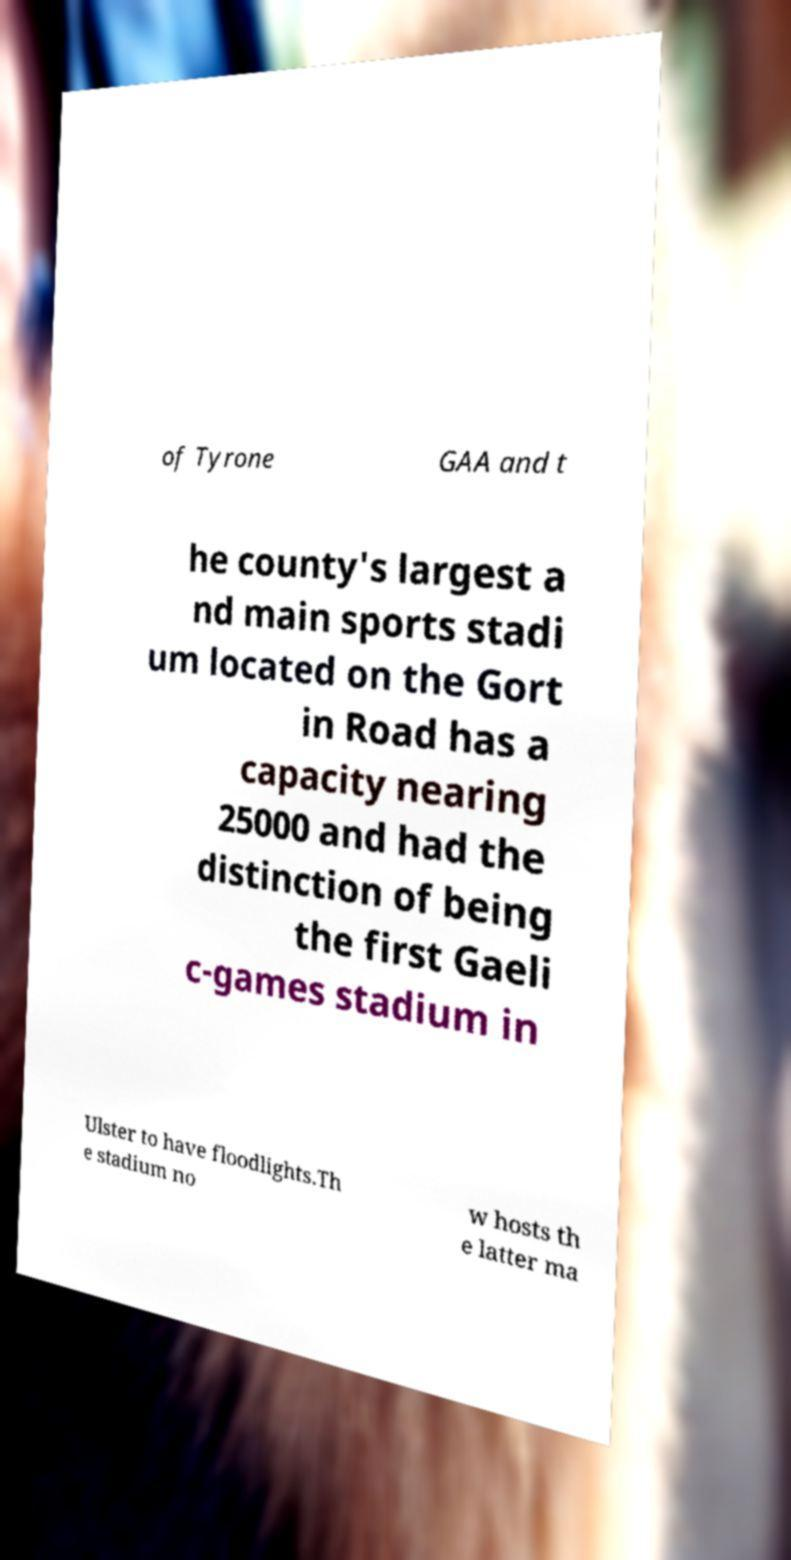I need the written content from this picture converted into text. Can you do that? of Tyrone GAA and t he county's largest a nd main sports stadi um located on the Gort in Road has a capacity nearing 25000 and had the distinction of being the first Gaeli c-games stadium in Ulster to have floodlights.Th e stadium no w hosts th e latter ma 